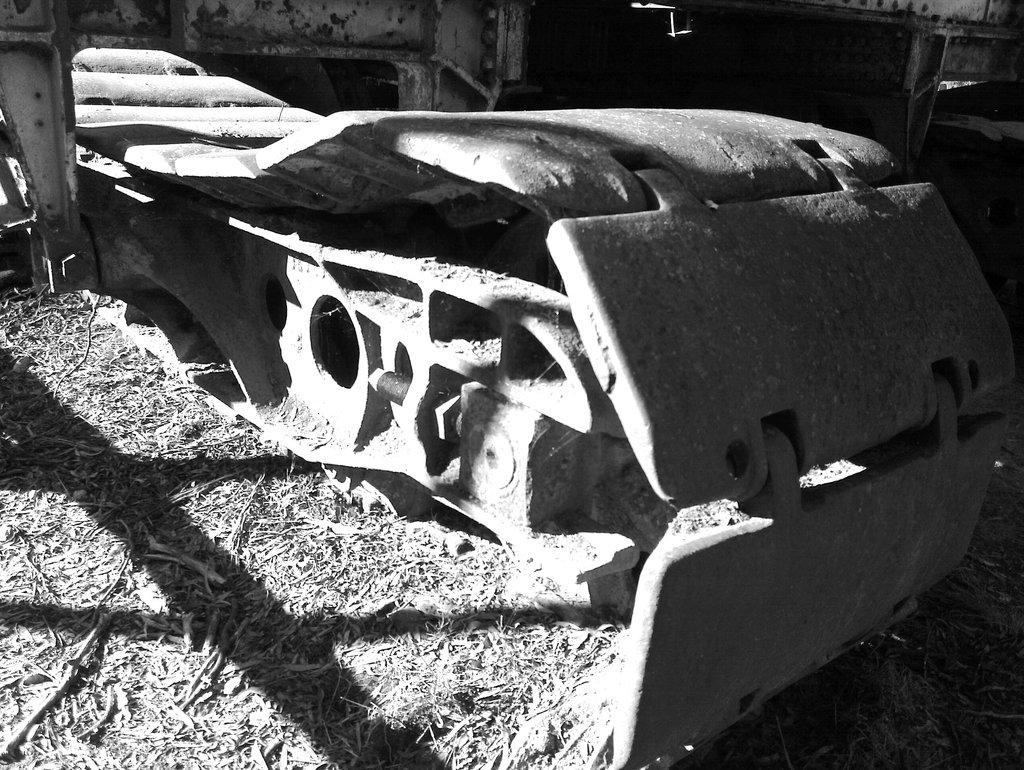What is the color scheme of the image? The image is black and white. What is the main subject in the image? There is a machine in the image. Where is the machine located? The machine is on dry grass. Can you describe the background of the image? There are a few things visible in the background of the image. What is the title of the book that the machine is reading in the image? There is no book or reading activity depicted in the image; it features a machine on dry grass. What is the current hour according to the clock in the image? There is no clock present in the image. 